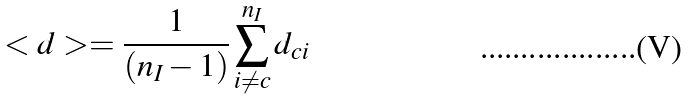Convert formula to latex. <formula><loc_0><loc_0><loc_500><loc_500>< d > = \frac { 1 } { ( n _ { I } - 1 ) } \sum _ { i \neq c } ^ { n _ { I } } d _ { c i }</formula> 